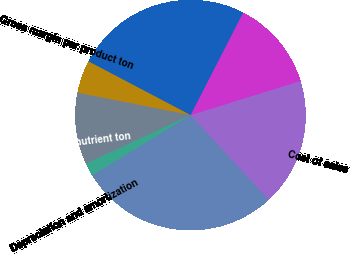Convert chart. <chart><loc_0><loc_0><loc_500><loc_500><pie_chart><fcel>Net sales<fcel>Cost of sales<fcel>Gross margin<fcel>Average selling price per<fcel>Gross margin per product ton<fcel>Gross margin per nutrient ton<fcel>Depreciation and amortization<nl><fcel>28.12%<fcel>17.92%<fcel>12.66%<fcel>24.84%<fcel>4.6%<fcel>10.03%<fcel>1.82%<nl></chart> 